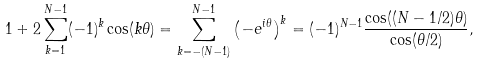Convert formula to latex. <formula><loc_0><loc_0><loc_500><loc_500>1 + 2 \sum _ { k = 1 } ^ { N - 1 } ( - 1 ) ^ { k } \cos ( k \theta ) & = \sum _ { k = - ( N - 1 ) } ^ { N - 1 } \left ( - e ^ { i \theta } \right ) ^ { k } = ( - 1 ) ^ { N - 1 } \frac { \cos ( ( N - 1 / 2 ) \theta ) } { \cos ( \theta / 2 ) } ,</formula> 